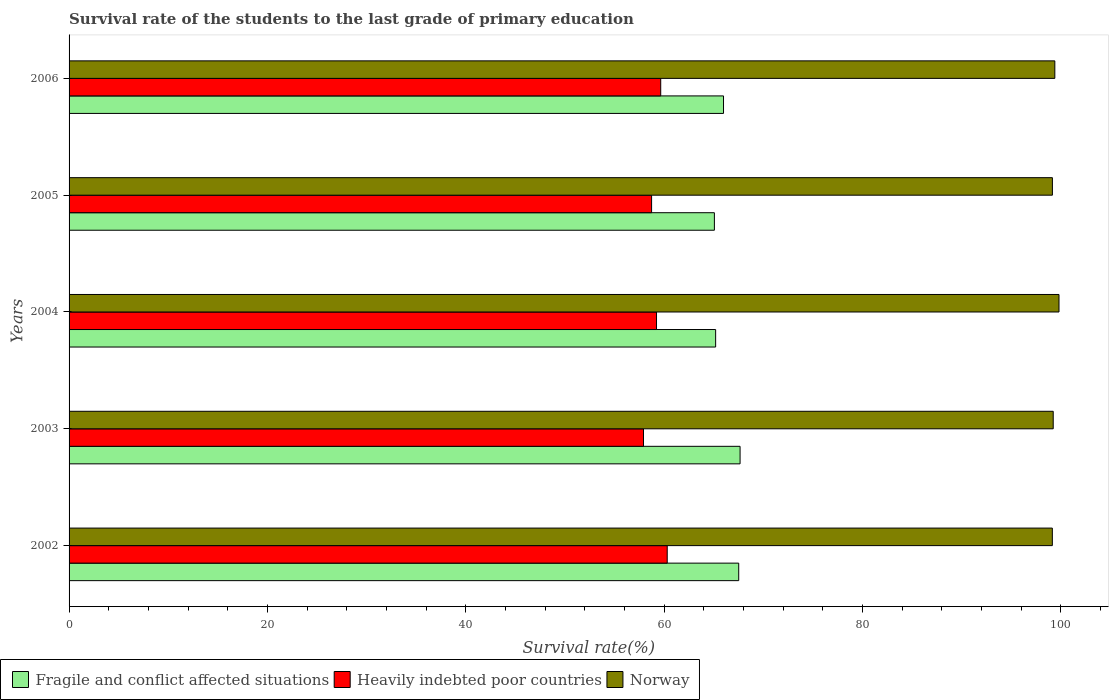How many groups of bars are there?
Ensure brevity in your answer.  5. Are the number of bars per tick equal to the number of legend labels?
Provide a short and direct response. Yes. How many bars are there on the 1st tick from the top?
Give a very brief answer. 3. In how many cases, is the number of bars for a given year not equal to the number of legend labels?
Provide a short and direct response. 0. What is the survival rate of the students in Heavily indebted poor countries in 2004?
Make the answer very short. 59.24. Across all years, what is the maximum survival rate of the students in Heavily indebted poor countries?
Ensure brevity in your answer.  60.32. Across all years, what is the minimum survival rate of the students in Norway?
Provide a succinct answer. 99.16. In which year was the survival rate of the students in Fragile and conflict affected situations maximum?
Provide a short and direct response. 2003. In which year was the survival rate of the students in Fragile and conflict affected situations minimum?
Give a very brief answer. 2005. What is the total survival rate of the students in Heavily indebted poor countries in the graph?
Your answer should be compact. 295.91. What is the difference between the survival rate of the students in Heavily indebted poor countries in 2002 and that in 2006?
Keep it short and to the point. 0.66. What is the difference between the survival rate of the students in Fragile and conflict affected situations in 2005 and the survival rate of the students in Norway in 2003?
Make the answer very short. -34.17. What is the average survival rate of the students in Fragile and conflict affected situations per year?
Offer a very short reply. 66.3. In the year 2003, what is the difference between the survival rate of the students in Norway and survival rate of the students in Fragile and conflict affected situations?
Keep it short and to the point. 31.58. What is the ratio of the survival rate of the students in Heavily indebted poor countries in 2005 to that in 2006?
Provide a succinct answer. 0.98. Is the survival rate of the students in Norway in 2002 less than that in 2006?
Provide a succinct answer. Yes. What is the difference between the highest and the second highest survival rate of the students in Heavily indebted poor countries?
Keep it short and to the point. 0.66. What is the difference between the highest and the lowest survival rate of the students in Norway?
Ensure brevity in your answer.  0.67. In how many years, is the survival rate of the students in Fragile and conflict affected situations greater than the average survival rate of the students in Fragile and conflict affected situations taken over all years?
Your answer should be very brief. 2. What does the 3rd bar from the top in 2005 represents?
Offer a very short reply. Fragile and conflict affected situations. What does the 3rd bar from the bottom in 2003 represents?
Provide a short and direct response. Norway. Is it the case that in every year, the sum of the survival rate of the students in Norway and survival rate of the students in Heavily indebted poor countries is greater than the survival rate of the students in Fragile and conflict affected situations?
Give a very brief answer. Yes. How many years are there in the graph?
Ensure brevity in your answer.  5. Does the graph contain grids?
Give a very brief answer. No. Where does the legend appear in the graph?
Your answer should be compact. Bottom left. How many legend labels are there?
Keep it short and to the point. 3. What is the title of the graph?
Your answer should be compact. Survival rate of the students to the last grade of primary education. Does "Nepal" appear as one of the legend labels in the graph?
Your response must be concise. No. What is the label or title of the X-axis?
Ensure brevity in your answer.  Survival rate(%). What is the label or title of the Y-axis?
Offer a terse response. Years. What is the Survival rate(%) of Fragile and conflict affected situations in 2002?
Provide a succinct answer. 67.53. What is the Survival rate(%) of Heavily indebted poor countries in 2002?
Offer a terse response. 60.32. What is the Survival rate(%) of Norway in 2002?
Offer a terse response. 99.16. What is the Survival rate(%) of Fragile and conflict affected situations in 2003?
Your answer should be very brief. 67.67. What is the Survival rate(%) in Heavily indebted poor countries in 2003?
Offer a terse response. 57.93. What is the Survival rate(%) in Norway in 2003?
Provide a succinct answer. 99.25. What is the Survival rate(%) in Fragile and conflict affected situations in 2004?
Your answer should be compact. 65.2. What is the Survival rate(%) of Heavily indebted poor countries in 2004?
Your answer should be compact. 59.24. What is the Survival rate(%) in Norway in 2004?
Your answer should be very brief. 99.83. What is the Survival rate(%) in Fragile and conflict affected situations in 2005?
Offer a very short reply. 65.08. What is the Survival rate(%) in Heavily indebted poor countries in 2005?
Give a very brief answer. 58.75. What is the Survival rate(%) of Norway in 2005?
Give a very brief answer. 99.17. What is the Survival rate(%) of Fragile and conflict affected situations in 2006?
Make the answer very short. 66. What is the Survival rate(%) of Heavily indebted poor countries in 2006?
Ensure brevity in your answer.  59.67. What is the Survival rate(%) of Norway in 2006?
Ensure brevity in your answer.  99.41. Across all years, what is the maximum Survival rate(%) in Fragile and conflict affected situations?
Make the answer very short. 67.67. Across all years, what is the maximum Survival rate(%) of Heavily indebted poor countries?
Make the answer very short. 60.32. Across all years, what is the maximum Survival rate(%) of Norway?
Your response must be concise. 99.83. Across all years, what is the minimum Survival rate(%) of Fragile and conflict affected situations?
Your answer should be compact. 65.08. Across all years, what is the minimum Survival rate(%) of Heavily indebted poor countries?
Keep it short and to the point. 57.93. Across all years, what is the minimum Survival rate(%) of Norway?
Your answer should be compact. 99.16. What is the total Survival rate(%) in Fragile and conflict affected situations in the graph?
Your response must be concise. 331.48. What is the total Survival rate(%) in Heavily indebted poor countries in the graph?
Provide a succinct answer. 295.91. What is the total Survival rate(%) of Norway in the graph?
Provide a succinct answer. 496.82. What is the difference between the Survival rate(%) of Fragile and conflict affected situations in 2002 and that in 2003?
Your response must be concise. -0.14. What is the difference between the Survival rate(%) in Heavily indebted poor countries in 2002 and that in 2003?
Provide a short and direct response. 2.39. What is the difference between the Survival rate(%) in Norway in 2002 and that in 2003?
Provide a succinct answer. -0.09. What is the difference between the Survival rate(%) in Fragile and conflict affected situations in 2002 and that in 2004?
Provide a short and direct response. 2.33. What is the difference between the Survival rate(%) in Heavily indebted poor countries in 2002 and that in 2004?
Offer a very short reply. 1.08. What is the difference between the Survival rate(%) in Norway in 2002 and that in 2004?
Keep it short and to the point. -0.67. What is the difference between the Survival rate(%) of Fragile and conflict affected situations in 2002 and that in 2005?
Give a very brief answer. 2.45. What is the difference between the Survival rate(%) in Heavily indebted poor countries in 2002 and that in 2005?
Give a very brief answer. 1.58. What is the difference between the Survival rate(%) of Norway in 2002 and that in 2005?
Your response must be concise. -0.01. What is the difference between the Survival rate(%) of Fragile and conflict affected situations in 2002 and that in 2006?
Your response must be concise. 1.53. What is the difference between the Survival rate(%) of Heavily indebted poor countries in 2002 and that in 2006?
Ensure brevity in your answer.  0.66. What is the difference between the Survival rate(%) in Norway in 2002 and that in 2006?
Offer a terse response. -0.25. What is the difference between the Survival rate(%) in Fragile and conflict affected situations in 2003 and that in 2004?
Provide a succinct answer. 2.46. What is the difference between the Survival rate(%) of Heavily indebted poor countries in 2003 and that in 2004?
Give a very brief answer. -1.31. What is the difference between the Survival rate(%) in Norway in 2003 and that in 2004?
Make the answer very short. -0.58. What is the difference between the Survival rate(%) of Fragile and conflict affected situations in 2003 and that in 2005?
Your response must be concise. 2.59. What is the difference between the Survival rate(%) in Heavily indebted poor countries in 2003 and that in 2005?
Your response must be concise. -0.82. What is the difference between the Survival rate(%) in Norway in 2003 and that in 2005?
Your response must be concise. 0.08. What is the difference between the Survival rate(%) in Fragile and conflict affected situations in 2003 and that in 2006?
Keep it short and to the point. 1.67. What is the difference between the Survival rate(%) of Heavily indebted poor countries in 2003 and that in 2006?
Offer a terse response. -1.74. What is the difference between the Survival rate(%) of Norway in 2003 and that in 2006?
Make the answer very short. -0.16. What is the difference between the Survival rate(%) in Fragile and conflict affected situations in 2004 and that in 2005?
Your response must be concise. 0.13. What is the difference between the Survival rate(%) of Heavily indebted poor countries in 2004 and that in 2005?
Offer a very short reply. 0.5. What is the difference between the Survival rate(%) of Norway in 2004 and that in 2005?
Ensure brevity in your answer.  0.66. What is the difference between the Survival rate(%) of Fragile and conflict affected situations in 2004 and that in 2006?
Give a very brief answer. -0.79. What is the difference between the Survival rate(%) of Heavily indebted poor countries in 2004 and that in 2006?
Your answer should be compact. -0.42. What is the difference between the Survival rate(%) in Norway in 2004 and that in 2006?
Offer a very short reply. 0.42. What is the difference between the Survival rate(%) in Fragile and conflict affected situations in 2005 and that in 2006?
Keep it short and to the point. -0.92. What is the difference between the Survival rate(%) in Heavily indebted poor countries in 2005 and that in 2006?
Make the answer very short. -0.92. What is the difference between the Survival rate(%) in Norway in 2005 and that in 2006?
Your response must be concise. -0.24. What is the difference between the Survival rate(%) in Fragile and conflict affected situations in 2002 and the Survival rate(%) in Heavily indebted poor countries in 2003?
Make the answer very short. 9.6. What is the difference between the Survival rate(%) of Fragile and conflict affected situations in 2002 and the Survival rate(%) of Norway in 2003?
Your response must be concise. -31.72. What is the difference between the Survival rate(%) in Heavily indebted poor countries in 2002 and the Survival rate(%) in Norway in 2003?
Ensure brevity in your answer.  -38.93. What is the difference between the Survival rate(%) in Fragile and conflict affected situations in 2002 and the Survival rate(%) in Heavily indebted poor countries in 2004?
Ensure brevity in your answer.  8.29. What is the difference between the Survival rate(%) in Fragile and conflict affected situations in 2002 and the Survival rate(%) in Norway in 2004?
Your answer should be very brief. -32.3. What is the difference between the Survival rate(%) in Heavily indebted poor countries in 2002 and the Survival rate(%) in Norway in 2004?
Your response must be concise. -39.51. What is the difference between the Survival rate(%) in Fragile and conflict affected situations in 2002 and the Survival rate(%) in Heavily indebted poor countries in 2005?
Offer a very short reply. 8.79. What is the difference between the Survival rate(%) of Fragile and conflict affected situations in 2002 and the Survival rate(%) of Norway in 2005?
Provide a short and direct response. -31.64. What is the difference between the Survival rate(%) in Heavily indebted poor countries in 2002 and the Survival rate(%) in Norway in 2005?
Your response must be concise. -38.85. What is the difference between the Survival rate(%) in Fragile and conflict affected situations in 2002 and the Survival rate(%) in Heavily indebted poor countries in 2006?
Keep it short and to the point. 7.87. What is the difference between the Survival rate(%) in Fragile and conflict affected situations in 2002 and the Survival rate(%) in Norway in 2006?
Offer a very short reply. -31.88. What is the difference between the Survival rate(%) in Heavily indebted poor countries in 2002 and the Survival rate(%) in Norway in 2006?
Your response must be concise. -39.09. What is the difference between the Survival rate(%) of Fragile and conflict affected situations in 2003 and the Survival rate(%) of Heavily indebted poor countries in 2004?
Provide a succinct answer. 8.43. What is the difference between the Survival rate(%) of Fragile and conflict affected situations in 2003 and the Survival rate(%) of Norway in 2004?
Offer a terse response. -32.16. What is the difference between the Survival rate(%) in Heavily indebted poor countries in 2003 and the Survival rate(%) in Norway in 2004?
Give a very brief answer. -41.9. What is the difference between the Survival rate(%) in Fragile and conflict affected situations in 2003 and the Survival rate(%) in Heavily indebted poor countries in 2005?
Keep it short and to the point. 8.92. What is the difference between the Survival rate(%) of Fragile and conflict affected situations in 2003 and the Survival rate(%) of Norway in 2005?
Ensure brevity in your answer.  -31.5. What is the difference between the Survival rate(%) in Heavily indebted poor countries in 2003 and the Survival rate(%) in Norway in 2005?
Give a very brief answer. -41.24. What is the difference between the Survival rate(%) in Fragile and conflict affected situations in 2003 and the Survival rate(%) in Heavily indebted poor countries in 2006?
Keep it short and to the point. 8. What is the difference between the Survival rate(%) of Fragile and conflict affected situations in 2003 and the Survival rate(%) of Norway in 2006?
Your answer should be very brief. -31.74. What is the difference between the Survival rate(%) in Heavily indebted poor countries in 2003 and the Survival rate(%) in Norway in 2006?
Ensure brevity in your answer.  -41.48. What is the difference between the Survival rate(%) in Fragile and conflict affected situations in 2004 and the Survival rate(%) in Heavily indebted poor countries in 2005?
Your answer should be compact. 6.46. What is the difference between the Survival rate(%) in Fragile and conflict affected situations in 2004 and the Survival rate(%) in Norway in 2005?
Ensure brevity in your answer.  -33.96. What is the difference between the Survival rate(%) in Heavily indebted poor countries in 2004 and the Survival rate(%) in Norway in 2005?
Your response must be concise. -39.92. What is the difference between the Survival rate(%) of Fragile and conflict affected situations in 2004 and the Survival rate(%) of Heavily indebted poor countries in 2006?
Offer a very short reply. 5.54. What is the difference between the Survival rate(%) in Fragile and conflict affected situations in 2004 and the Survival rate(%) in Norway in 2006?
Make the answer very short. -34.21. What is the difference between the Survival rate(%) of Heavily indebted poor countries in 2004 and the Survival rate(%) of Norway in 2006?
Your answer should be very brief. -40.17. What is the difference between the Survival rate(%) of Fragile and conflict affected situations in 2005 and the Survival rate(%) of Heavily indebted poor countries in 2006?
Keep it short and to the point. 5.41. What is the difference between the Survival rate(%) in Fragile and conflict affected situations in 2005 and the Survival rate(%) in Norway in 2006?
Keep it short and to the point. -34.33. What is the difference between the Survival rate(%) of Heavily indebted poor countries in 2005 and the Survival rate(%) of Norway in 2006?
Provide a succinct answer. -40.67. What is the average Survival rate(%) in Fragile and conflict affected situations per year?
Offer a very short reply. 66.3. What is the average Survival rate(%) of Heavily indebted poor countries per year?
Your answer should be compact. 59.18. What is the average Survival rate(%) in Norway per year?
Provide a succinct answer. 99.36. In the year 2002, what is the difference between the Survival rate(%) in Fragile and conflict affected situations and Survival rate(%) in Heavily indebted poor countries?
Keep it short and to the point. 7.21. In the year 2002, what is the difference between the Survival rate(%) in Fragile and conflict affected situations and Survival rate(%) in Norway?
Your answer should be compact. -31.63. In the year 2002, what is the difference between the Survival rate(%) in Heavily indebted poor countries and Survival rate(%) in Norway?
Your answer should be compact. -38.84. In the year 2003, what is the difference between the Survival rate(%) in Fragile and conflict affected situations and Survival rate(%) in Heavily indebted poor countries?
Your answer should be compact. 9.74. In the year 2003, what is the difference between the Survival rate(%) of Fragile and conflict affected situations and Survival rate(%) of Norway?
Your response must be concise. -31.58. In the year 2003, what is the difference between the Survival rate(%) in Heavily indebted poor countries and Survival rate(%) in Norway?
Offer a terse response. -41.32. In the year 2004, what is the difference between the Survival rate(%) of Fragile and conflict affected situations and Survival rate(%) of Heavily indebted poor countries?
Your answer should be compact. 5.96. In the year 2004, what is the difference between the Survival rate(%) of Fragile and conflict affected situations and Survival rate(%) of Norway?
Your answer should be very brief. -34.63. In the year 2004, what is the difference between the Survival rate(%) of Heavily indebted poor countries and Survival rate(%) of Norway?
Ensure brevity in your answer.  -40.59. In the year 2005, what is the difference between the Survival rate(%) of Fragile and conflict affected situations and Survival rate(%) of Heavily indebted poor countries?
Provide a short and direct response. 6.33. In the year 2005, what is the difference between the Survival rate(%) of Fragile and conflict affected situations and Survival rate(%) of Norway?
Your response must be concise. -34.09. In the year 2005, what is the difference between the Survival rate(%) in Heavily indebted poor countries and Survival rate(%) in Norway?
Provide a short and direct response. -40.42. In the year 2006, what is the difference between the Survival rate(%) of Fragile and conflict affected situations and Survival rate(%) of Heavily indebted poor countries?
Give a very brief answer. 6.33. In the year 2006, what is the difference between the Survival rate(%) of Fragile and conflict affected situations and Survival rate(%) of Norway?
Your response must be concise. -33.41. In the year 2006, what is the difference between the Survival rate(%) of Heavily indebted poor countries and Survival rate(%) of Norway?
Offer a terse response. -39.75. What is the ratio of the Survival rate(%) in Fragile and conflict affected situations in 2002 to that in 2003?
Provide a succinct answer. 1. What is the ratio of the Survival rate(%) in Heavily indebted poor countries in 2002 to that in 2003?
Provide a succinct answer. 1.04. What is the ratio of the Survival rate(%) of Fragile and conflict affected situations in 2002 to that in 2004?
Give a very brief answer. 1.04. What is the ratio of the Survival rate(%) of Heavily indebted poor countries in 2002 to that in 2004?
Your answer should be very brief. 1.02. What is the ratio of the Survival rate(%) in Fragile and conflict affected situations in 2002 to that in 2005?
Ensure brevity in your answer.  1.04. What is the ratio of the Survival rate(%) in Heavily indebted poor countries in 2002 to that in 2005?
Provide a succinct answer. 1.03. What is the ratio of the Survival rate(%) in Fragile and conflict affected situations in 2002 to that in 2006?
Your response must be concise. 1.02. What is the ratio of the Survival rate(%) of Heavily indebted poor countries in 2002 to that in 2006?
Your answer should be compact. 1.01. What is the ratio of the Survival rate(%) of Norway in 2002 to that in 2006?
Offer a terse response. 1. What is the ratio of the Survival rate(%) of Fragile and conflict affected situations in 2003 to that in 2004?
Offer a terse response. 1.04. What is the ratio of the Survival rate(%) of Heavily indebted poor countries in 2003 to that in 2004?
Keep it short and to the point. 0.98. What is the ratio of the Survival rate(%) of Norway in 2003 to that in 2004?
Keep it short and to the point. 0.99. What is the ratio of the Survival rate(%) of Fragile and conflict affected situations in 2003 to that in 2005?
Offer a very short reply. 1.04. What is the ratio of the Survival rate(%) in Heavily indebted poor countries in 2003 to that in 2005?
Give a very brief answer. 0.99. What is the ratio of the Survival rate(%) in Norway in 2003 to that in 2005?
Your answer should be very brief. 1. What is the ratio of the Survival rate(%) in Fragile and conflict affected situations in 2003 to that in 2006?
Your answer should be very brief. 1.03. What is the ratio of the Survival rate(%) of Heavily indebted poor countries in 2003 to that in 2006?
Keep it short and to the point. 0.97. What is the ratio of the Survival rate(%) of Fragile and conflict affected situations in 2004 to that in 2005?
Your response must be concise. 1. What is the ratio of the Survival rate(%) in Heavily indebted poor countries in 2004 to that in 2005?
Ensure brevity in your answer.  1.01. What is the ratio of the Survival rate(%) of Norway in 2004 to that in 2005?
Keep it short and to the point. 1.01. What is the ratio of the Survival rate(%) of Fragile and conflict affected situations in 2005 to that in 2006?
Provide a short and direct response. 0.99. What is the ratio of the Survival rate(%) in Heavily indebted poor countries in 2005 to that in 2006?
Make the answer very short. 0.98. What is the difference between the highest and the second highest Survival rate(%) of Fragile and conflict affected situations?
Provide a succinct answer. 0.14. What is the difference between the highest and the second highest Survival rate(%) of Heavily indebted poor countries?
Your response must be concise. 0.66. What is the difference between the highest and the second highest Survival rate(%) in Norway?
Ensure brevity in your answer.  0.42. What is the difference between the highest and the lowest Survival rate(%) in Fragile and conflict affected situations?
Keep it short and to the point. 2.59. What is the difference between the highest and the lowest Survival rate(%) in Heavily indebted poor countries?
Your answer should be compact. 2.39. What is the difference between the highest and the lowest Survival rate(%) in Norway?
Provide a succinct answer. 0.67. 